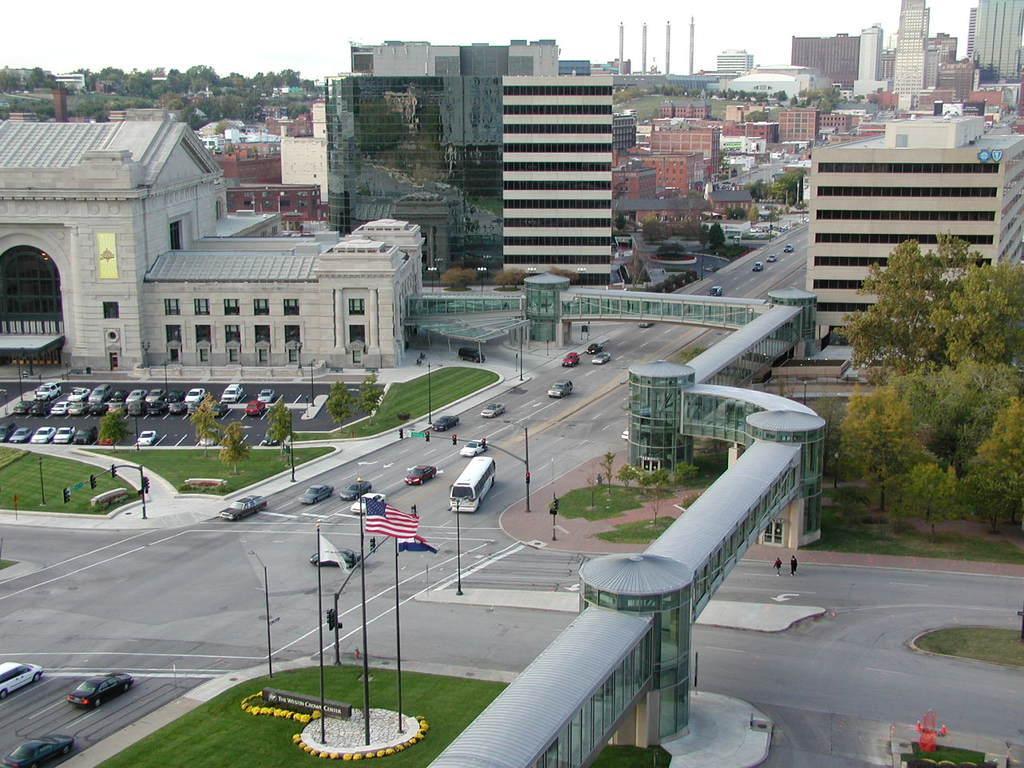Could you give a brief overview of what you see in this image? In this picture we can see so many buildings, trees, grass, vehicles are on the road. 